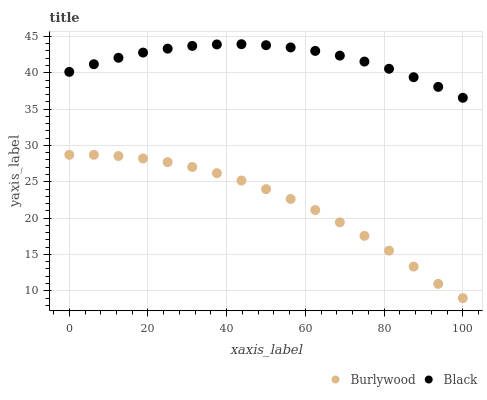Does Burlywood have the minimum area under the curve?
Answer yes or no. Yes. Does Black have the maximum area under the curve?
Answer yes or no. Yes. Does Black have the minimum area under the curve?
Answer yes or no. No. Is Black the smoothest?
Answer yes or no. Yes. Is Burlywood the roughest?
Answer yes or no. Yes. Is Black the roughest?
Answer yes or no. No. Does Burlywood have the lowest value?
Answer yes or no. Yes. Does Black have the lowest value?
Answer yes or no. No. Does Black have the highest value?
Answer yes or no. Yes. Is Burlywood less than Black?
Answer yes or no. Yes. Is Black greater than Burlywood?
Answer yes or no. Yes. Does Burlywood intersect Black?
Answer yes or no. No. 